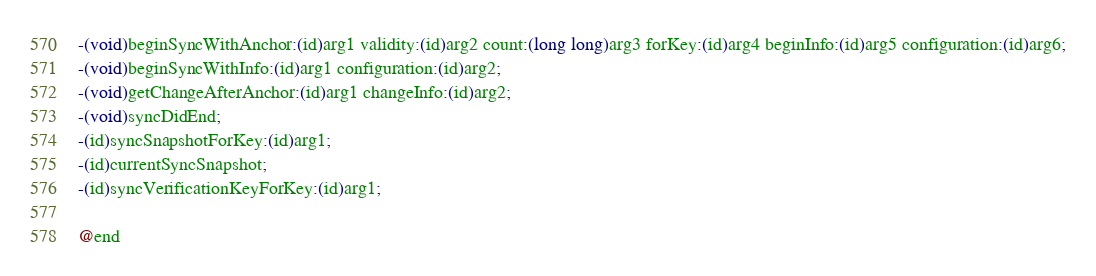<code> <loc_0><loc_0><loc_500><loc_500><_C_>-(void)beginSyncWithAnchor:(id)arg1 validity:(id)arg2 count:(long long)arg3 forKey:(id)arg4 beginInfo:(id)arg5 configuration:(id)arg6;
-(void)beginSyncWithInfo:(id)arg1 configuration:(id)arg2;
-(void)getChangeAfterAnchor:(id)arg1 changeInfo:(id)arg2;
-(void)syncDidEnd;
-(id)syncSnapshotForKey:(id)arg1;
-(id)currentSyncSnapshot;
-(id)syncVerificationKeyForKey:(id)arg1;

@end

</code> 